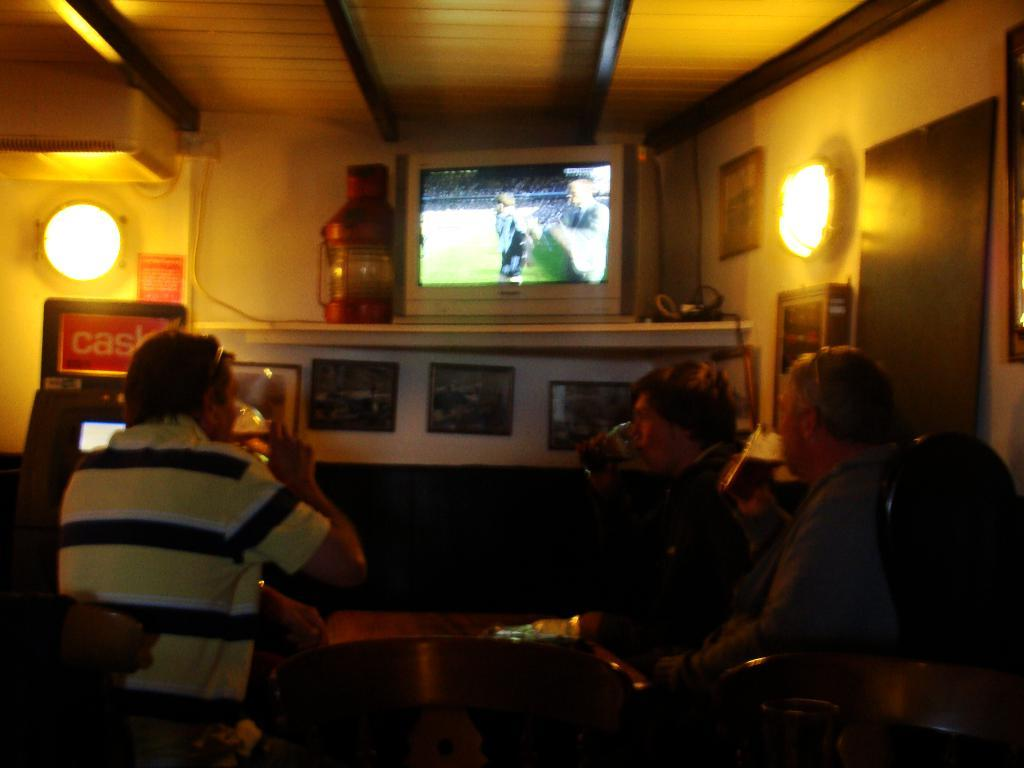What are the people in the image doing? The people in the image are sitting and drinking. What can be seen in the background of the image? There is a television, lights, a wall, and other objects in the background. Can you describe the television in the background? The television is in the background, but its specific features are not visible in the image. What type of pest can be seen in the image? There is no pest present in the image. What animals can be seen at the zoo in the image? There is no zoo or animals present in the image. 